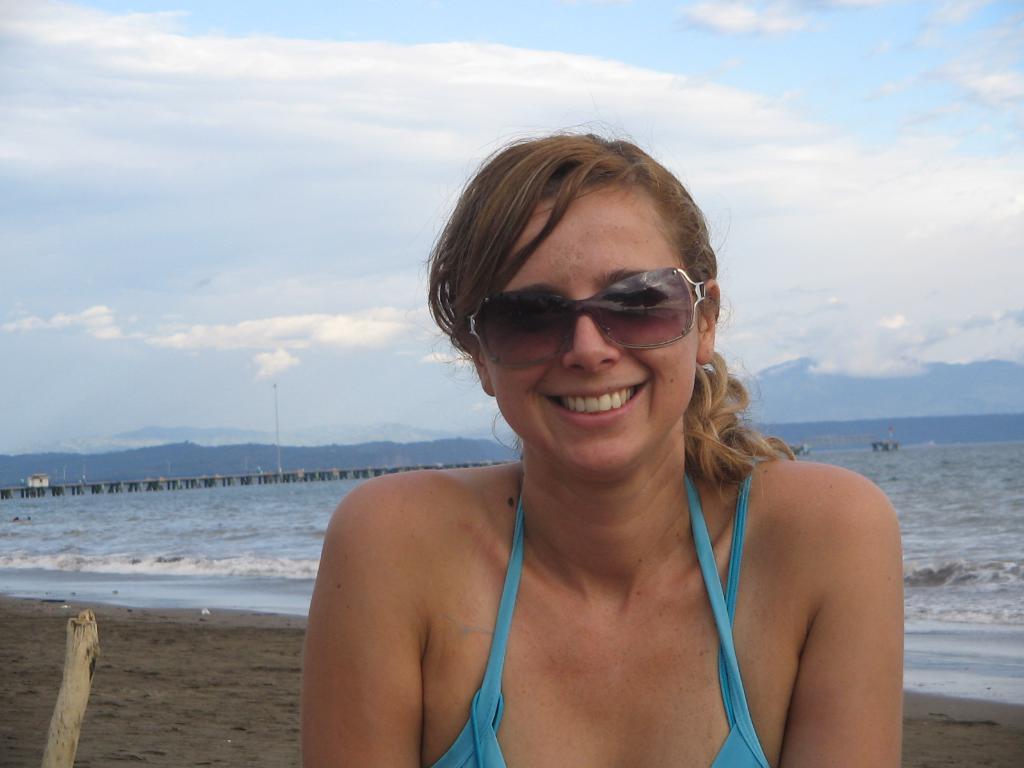Describe this image in one or two sentences. In this picture there is a girl in the center of the image and there is water in the background area of the image, there is a bamboo at the bottom side of the image. 